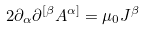Convert formula to latex. <formula><loc_0><loc_0><loc_500><loc_500>2 \partial _ { \alpha } \partial ^ { [ \beta } A ^ { \alpha ] } = \mu _ { 0 } J ^ { \beta }</formula> 